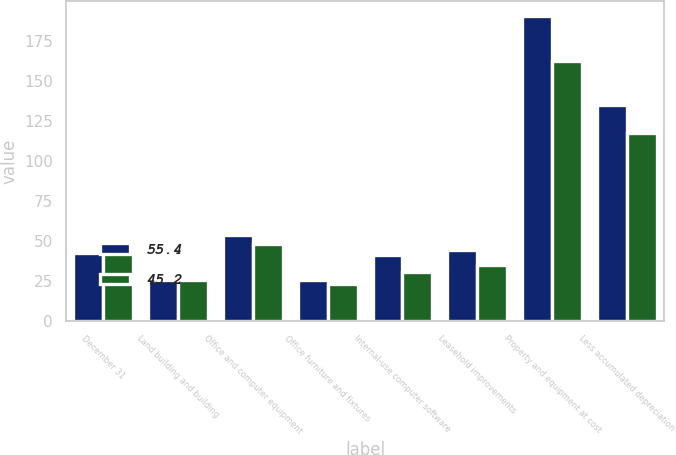Convert chart to OTSL. <chart><loc_0><loc_0><loc_500><loc_500><stacked_bar_chart><ecel><fcel>December 31<fcel>Land building and building<fcel>Office and computer equipment<fcel>Office furniture and fixtures<fcel>Internal-use computer software<fcel>Leasehold improvements<fcel>Property and equipment at cost<fcel>Less accumulated depreciation<nl><fcel>55.4<fcel>42.7<fcel>25.8<fcel>53.7<fcel>25.4<fcel>41.4<fcel>44<fcel>190.3<fcel>134.9<nl><fcel>45.2<fcel>42.7<fcel>25.4<fcel>48.1<fcel>23<fcel>30.7<fcel>35.1<fcel>162.3<fcel>117.1<nl></chart> 